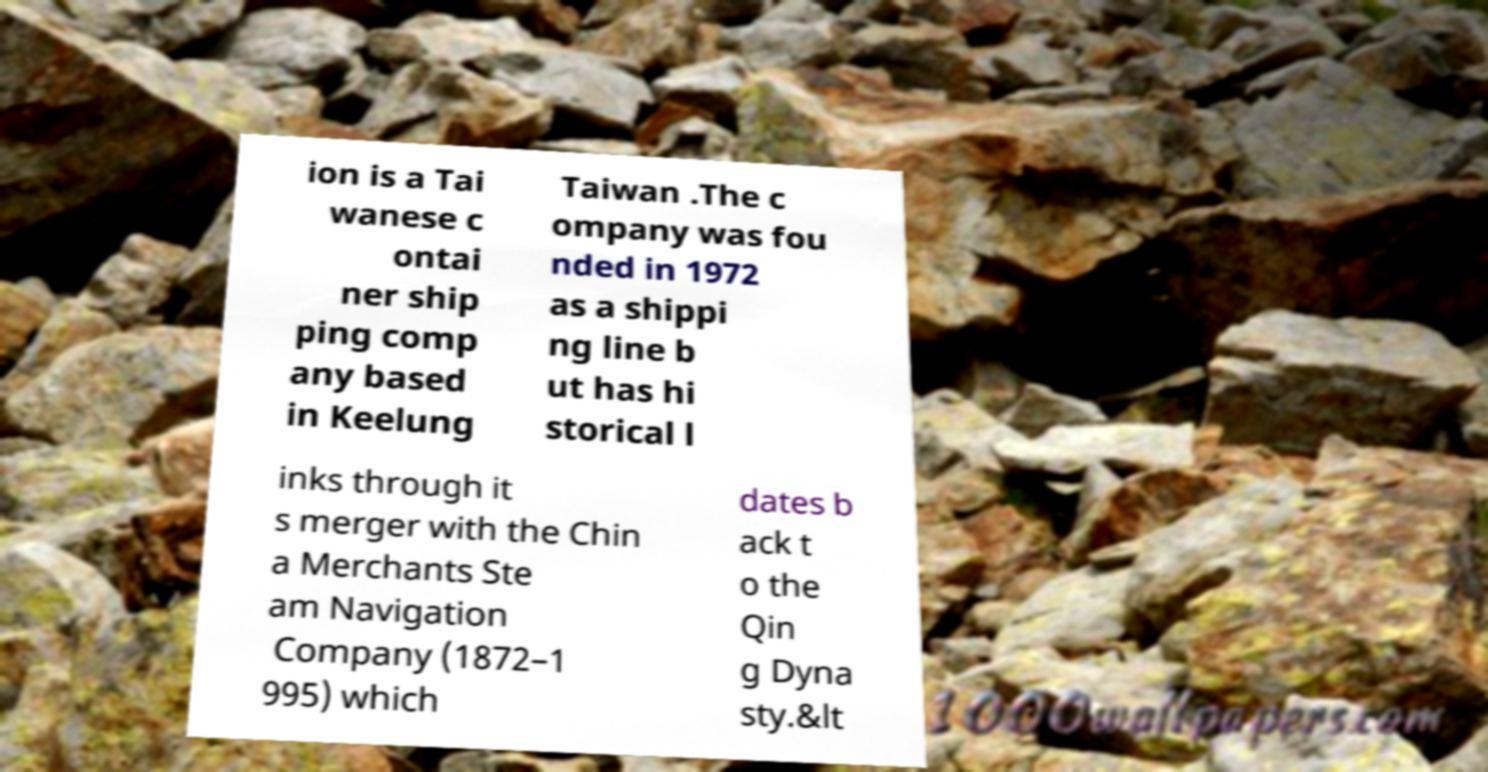Please identify and transcribe the text found in this image. ion is a Tai wanese c ontai ner ship ping comp any based in Keelung Taiwan .The c ompany was fou nded in 1972 as a shippi ng line b ut has hi storical l inks through it s merger with the Chin a Merchants Ste am Navigation Company (1872–1 995) which dates b ack t o the Qin g Dyna sty.&lt 